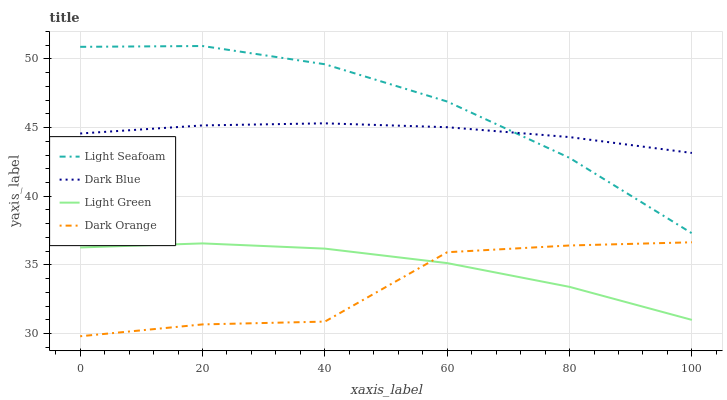Does Dark Orange have the minimum area under the curve?
Answer yes or no. Yes. Does Light Seafoam have the maximum area under the curve?
Answer yes or no. Yes. Does Light Green have the minimum area under the curve?
Answer yes or no. No. Does Light Green have the maximum area under the curve?
Answer yes or no. No. Is Dark Blue the smoothest?
Answer yes or no. Yes. Is Dark Orange the roughest?
Answer yes or no. Yes. Is Light Seafoam the smoothest?
Answer yes or no. No. Is Light Seafoam the roughest?
Answer yes or no. No. Does Dark Orange have the lowest value?
Answer yes or no. Yes. Does Light Seafoam have the lowest value?
Answer yes or no. No. Does Light Seafoam have the highest value?
Answer yes or no. Yes. Does Light Green have the highest value?
Answer yes or no. No. Is Light Green less than Light Seafoam?
Answer yes or no. Yes. Is Light Seafoam greater than Light Green?
Answer yes or no. Yes. Does Dark Orange intersect Light Green?
Answer yes or no. Yes. Is Dark Orange less than Light Green?
Answer yes or no. No. Is Dark Orange greater than Light Green?
Answer yes or no. No. Does Light Green intersect Light Seafoam?
Answer yes or no. No. 